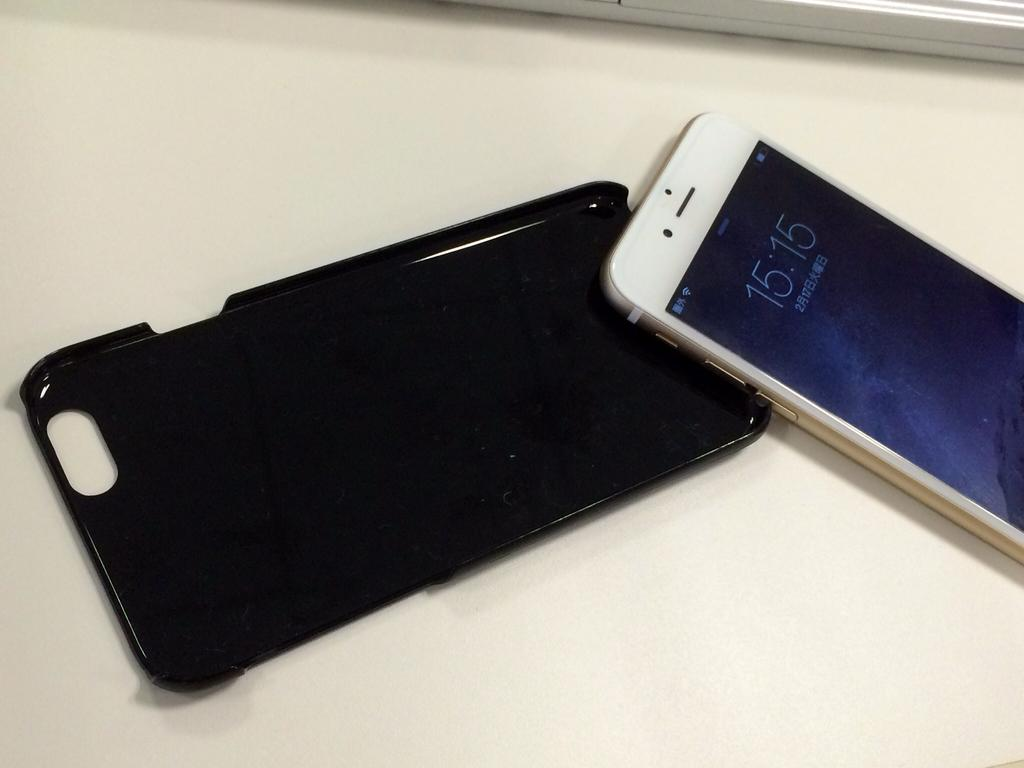<image>
Share a concise interpretation of the image provided. 15:15 reads the time on this smart phone display. 